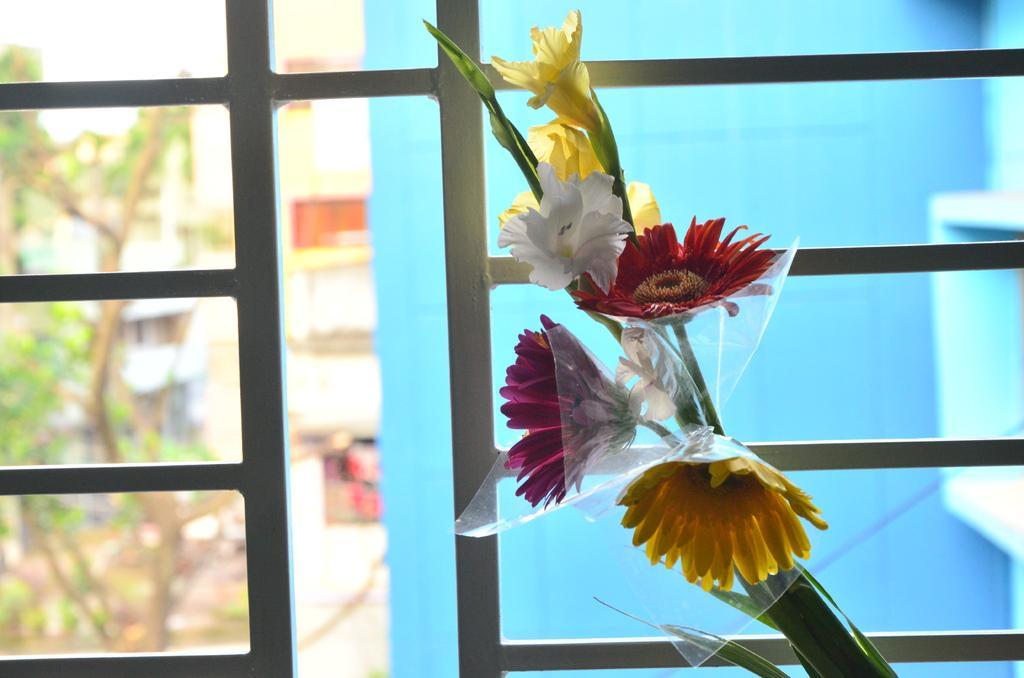In one or two sentences, can you explain what this image depicts? In the foreground of the image there are flowers. In the background of the image there is a grill. There are trees and buildings. 